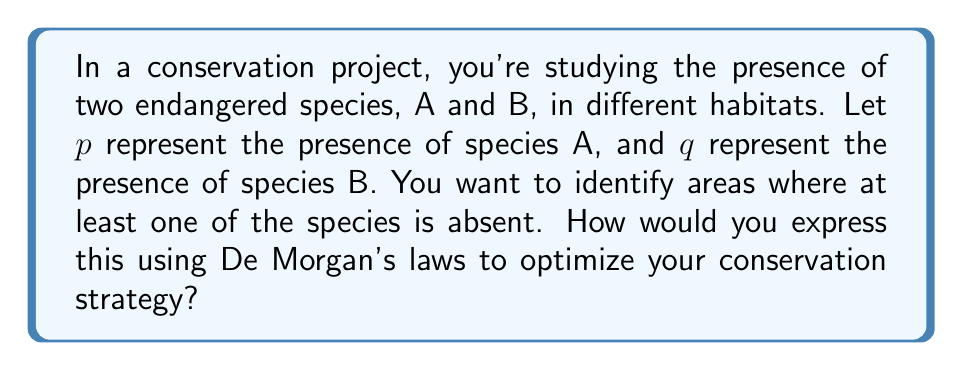Show me your answer to this math problem. Let's approach this step-by-step:

1) First, we need to understand what we're looking for. We want areas where "at least one of the species is absent". This is equivalent to "not (both species are present)".

2) If we were to express "both species are present", we would write this as:

   $p \land q$

3) Therefore, "at least one of the species is absent" can be expressed as:

   $\lnot(p \land q)$

4) Now, we can apply De Morgan's law to this expression. De Morgan's law states that:

   $\lnot(X \land Y) \equiv \lnot X \lor \lnot Y$

5) Applying this to our expression:

   $\lnot(p \land q) \equiv \lnot p \lor \lnot q$

6) This simplified expression means "species A is absent OR species B is absent".

7) In terms of conservation strategy, this optimized expression allows us to focus on areas where either species A is absent or species B is absent, which might indicate habitats that need improvement or protection to support both species.
Answer: $\lnot p \lor \lnot q$ 